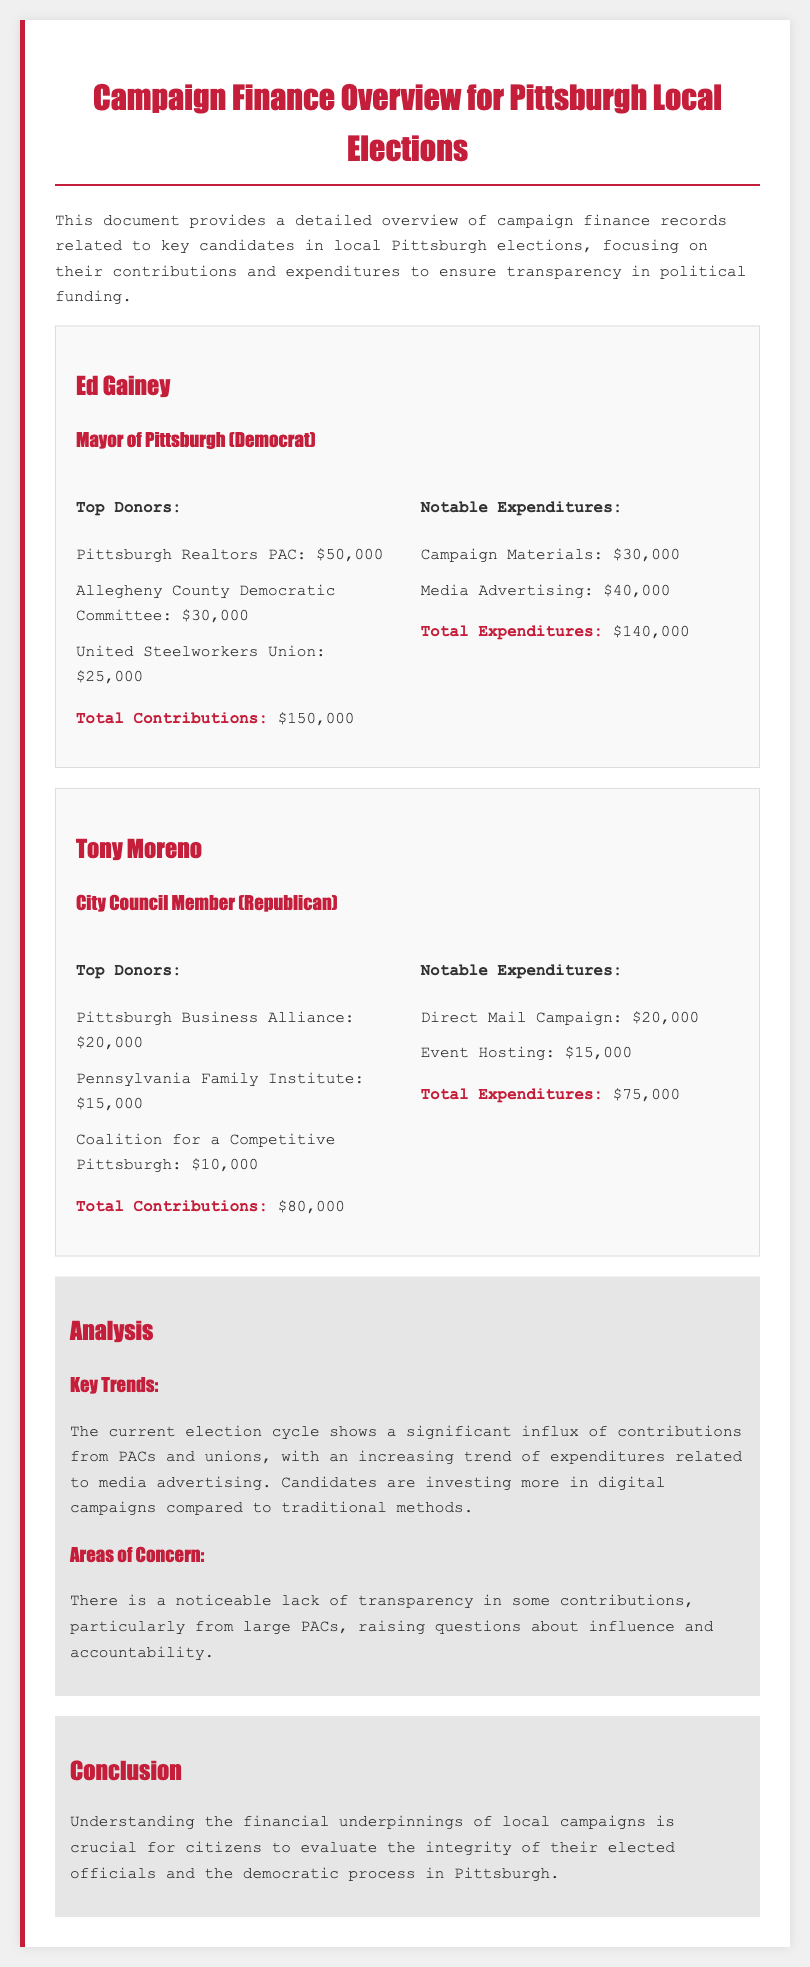What is the name of the candidate for Mayor of Pittsburgh? The document lists Ed Gainey as the candidate for Mayor of Pittsburgh.
Answer: Ed Gainey How much did the United Steelworkers Union contribute? Total contributions from the United Steelworkers Union is specified as $25,000 in the document.
Answer: $25,000 What is the total expenditure for Tony Moreno? The document states that Tony Moreno's total expenditures are $75,000.
Answer: $75,000 Which political committee contributed $30,000 to Ed Gainey? The Allegheny County Democratic Committee is identified as having contributed $30,000 to Ed Gainey.
Answer: Allegheny County Democratic Committee What notable expenditure was reported for Ed Gainey? The document highlights campaign materials as a notable expenditure for Ed Gainey, amounting to $30,000.
Answer: Campaign Materials Which type of campaign expenditure is increasing according to the key trends analysis? The analysis indicates an increasing trend in expenditures related to media advertising.
Answer: Media Advertising What area does this document focus on? The focus of the document is on campaign finance records for local Pittsburgh elections.
Answer: Campaign finance records What is the total contribution from the Pittsburgh Realtors PAC? The contribution from the Pittsburgh Realtors PAC is specified as $50,000 in the document.
Answer: $50,000 What is a concern mentioned in the document regarding contributions? The document raises concerns about the lack of transparency in contributions from large PACs.
Answer: Lack of transparency 